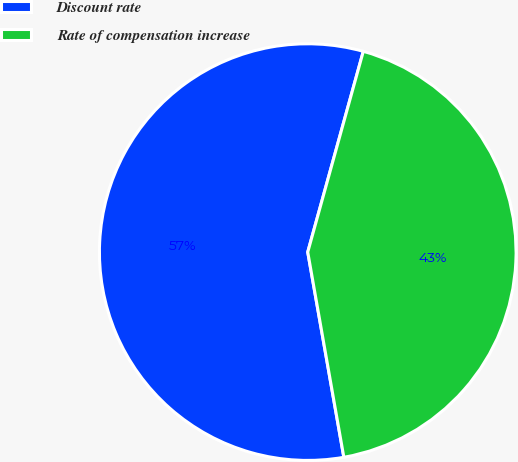Convert chart. <chart><loc_0><loc_0><loc_500><loc_500><pie_chart><fcel>Discount rate<fcel>Rate of compensation increase<nl><fcel>57.07%<fcel>42.93%<nl></chart> 